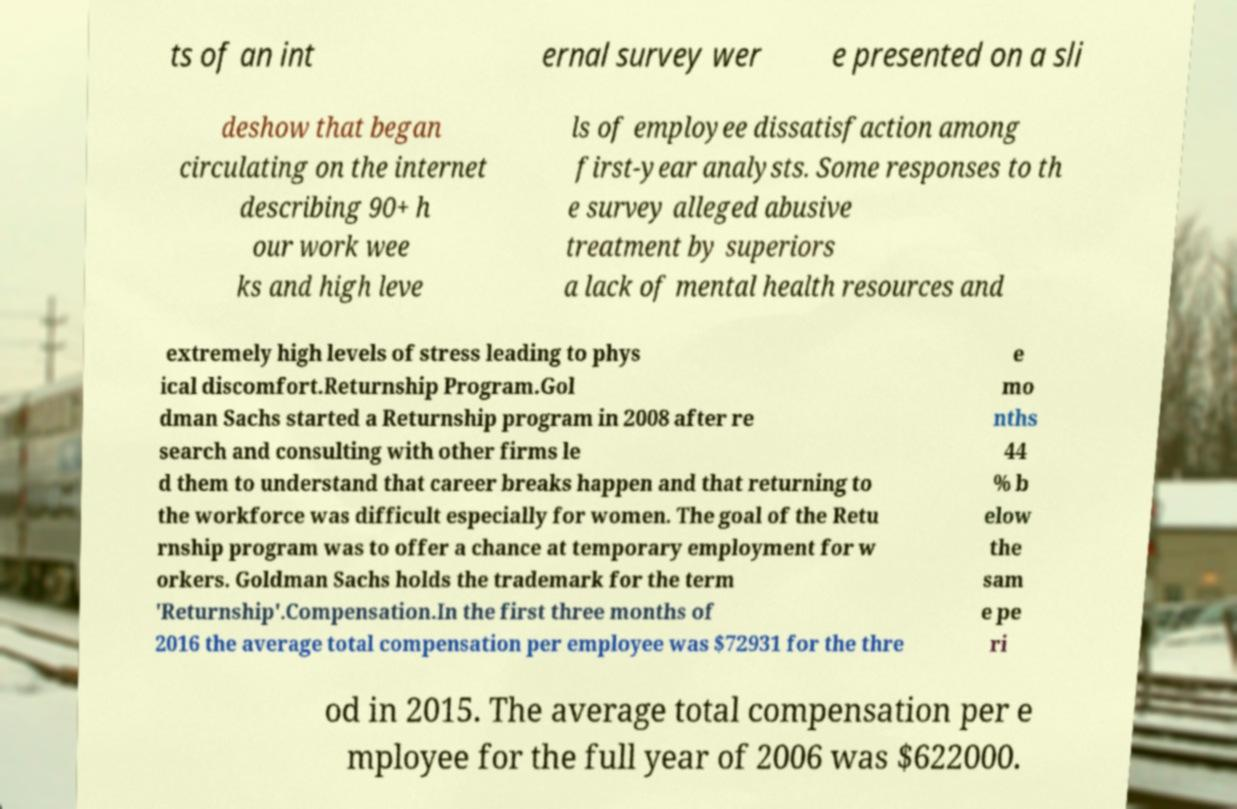For documentation purposes, I need the text within this image transcribed. Could you provide that? ts of an int ernal survey wer e presented on a sli deshow that began circulating on the internet describing 90+ h our work wee ks and high leve ls of employee dissatisfaction among first-year analysts. Some responses to th e survey alleged abusive treatment by superiors a lack of mental health resources and extremely high levels of stress leading to phys ical discomfort.Returnship Program.Gol dman Sachs started a Returnship program in 2008 after re search and consulting with other firms le d them to understand that career breaks happen and that returning to the workforce was difficult especially for women. The goal of the Retu rnship program was to offer a chance at temporary employment for w orkers. Goldman Sachs holds the trademark for the term 'Returnship'.Compensation.In the first three months of 2016 the average total compensation per employee was $72931 for the thre e mo nths 44 % b elow the sam e pe ri od in 2015. The average total compensation per e mployee for the full year of 2006 was $622000. 